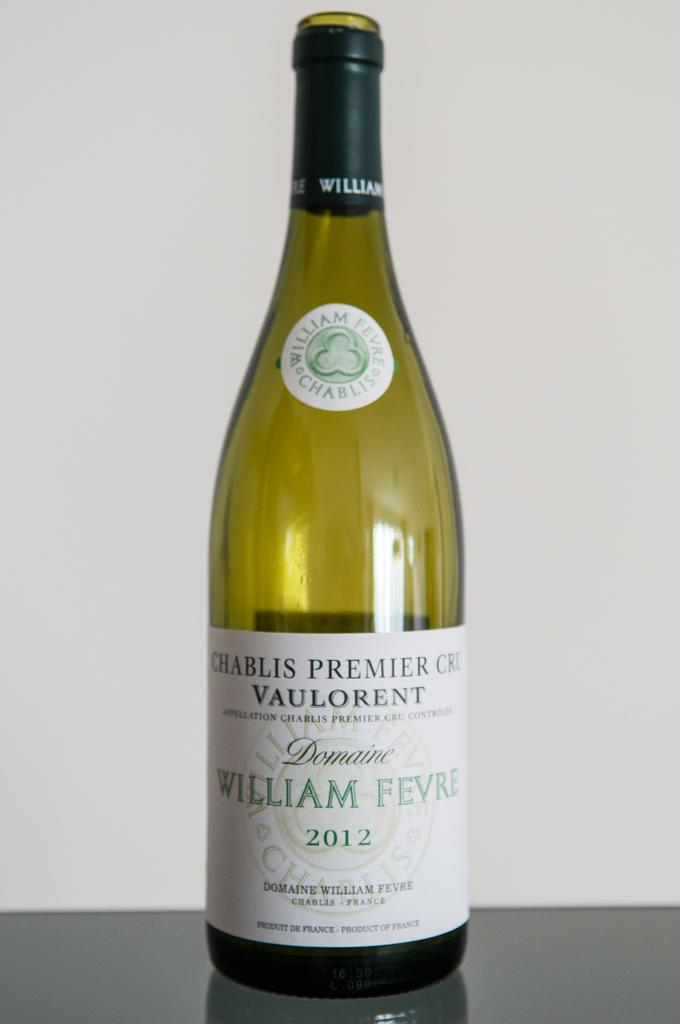<image>
Render a clear and concise summary of the photo. A bottle of Chablis Premier Cru Vaulorent is sitting on a table. 